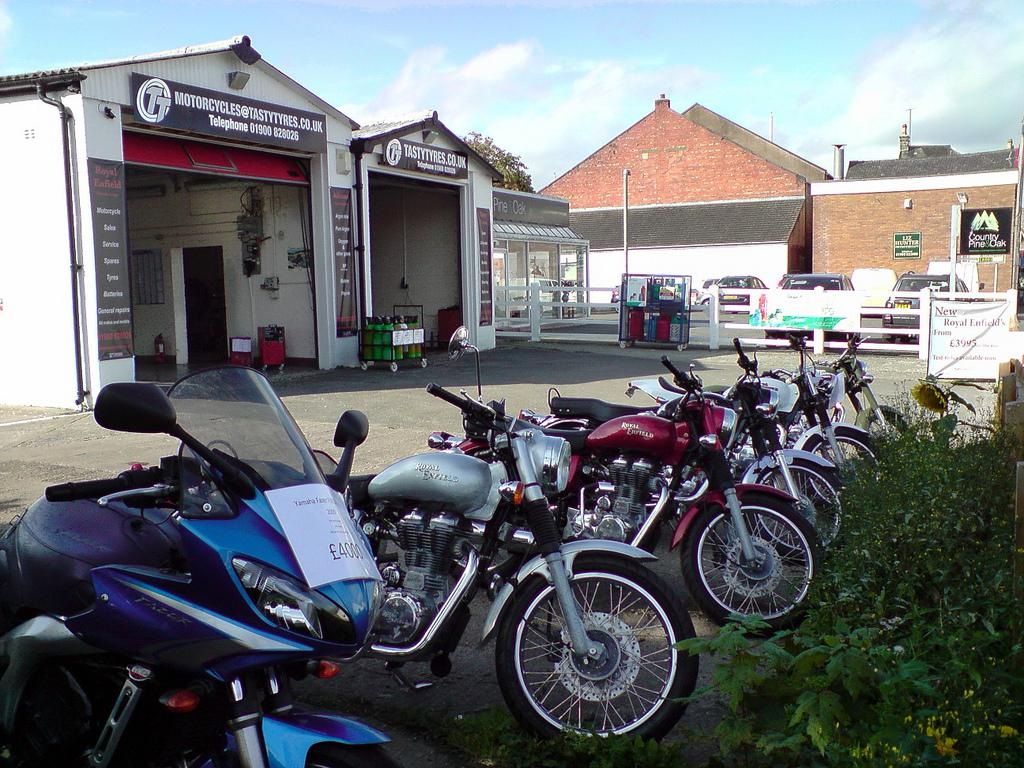Question: what is on ground?
Choices:
A. Snow.
B. Shadows.
C. Rain drops.
D. Toys.
Answer with the letter. Answer: B Question: why are the motorcycles outside?
Choices:
A. They are for sale.
B. There's no room in the garage.
C. Because the owners are in the restaurant.
D. There is no indoor parking.
Answer with the letter. Answer: A Question: what is for sale?
Choices:
A. Everything.
B. The house.
C. A car.
D. The motorcycle in front.
Answer with the letter. Answer: D Question: what colors are the motorcycles?
Choices:
A. Green, blue, and pink.
B. White, blue silver and red.
C. Orange, white, and yellow.
D. Black, white, and red.
Answer with the letter. Answer: B Question: what are facing same way?
Choices:
A. Cars.
B. Trucks.
C. Motorbikes.
D. Bicycles.
Answer with the letter. Answer: C Question: what was the weather like?
Choices:
A. Sunny.
B. Raining.
C. Hot and muggy.
D. Windy.
Answer with the letter. Answer: A Question: how many motorcycles are in the picture?
Choices:
A. Six.
B. Fourteen.
C. One.
D. Ten.
Answer with the letter. Answer: A Question: what is the building in the background made of?
Choices:
A. Stone.
B. Stucco.
C. Cement and glass.
D. Bricks.
Answer with the letter. Answer: D Question: how many white buildings are shown?
Choices:
A. Two.
B. Three.
C. Four.
D. Five.
Answer with the letter. Answer: A Question: what sort of weather is in the photo?
Choices:
A. Windy.
B. Partly cloudy.
C. Bright and sunny.
D. Hot and sunny.
Answer with the letter. Answer: B Question: how many cars are parked?
Choices:
A. Four.
B. Five.
C. None.
D. Three.
Answer with the letter. Answer: D Question: what position are the garage doors in?
Choices:
A. Closed.
B. Half open.
C. They are closing.
D. Open.
Answer with the letter. Answer: D Question: where are there weeds growing?
Choices:
A. In the garden.
B. In the cracks of the sidewalk.
C. On the right side.
D. Near the tree.
Answer with the letter. Answer: C Question: where are the motorcycles parked?
Choices:
A. Outside of a bar.
B. At a gas station.
C. At a repair shop.
D. Behind the all night diner.
Answer with the letter. Answer: C Question: what is this a picture of?
Choices:
A. Cars in  a garage.
B. Motorcycles and a garage.
C. Bikes.
D. Motorcycles.
Answer with the letter. Answer: B 